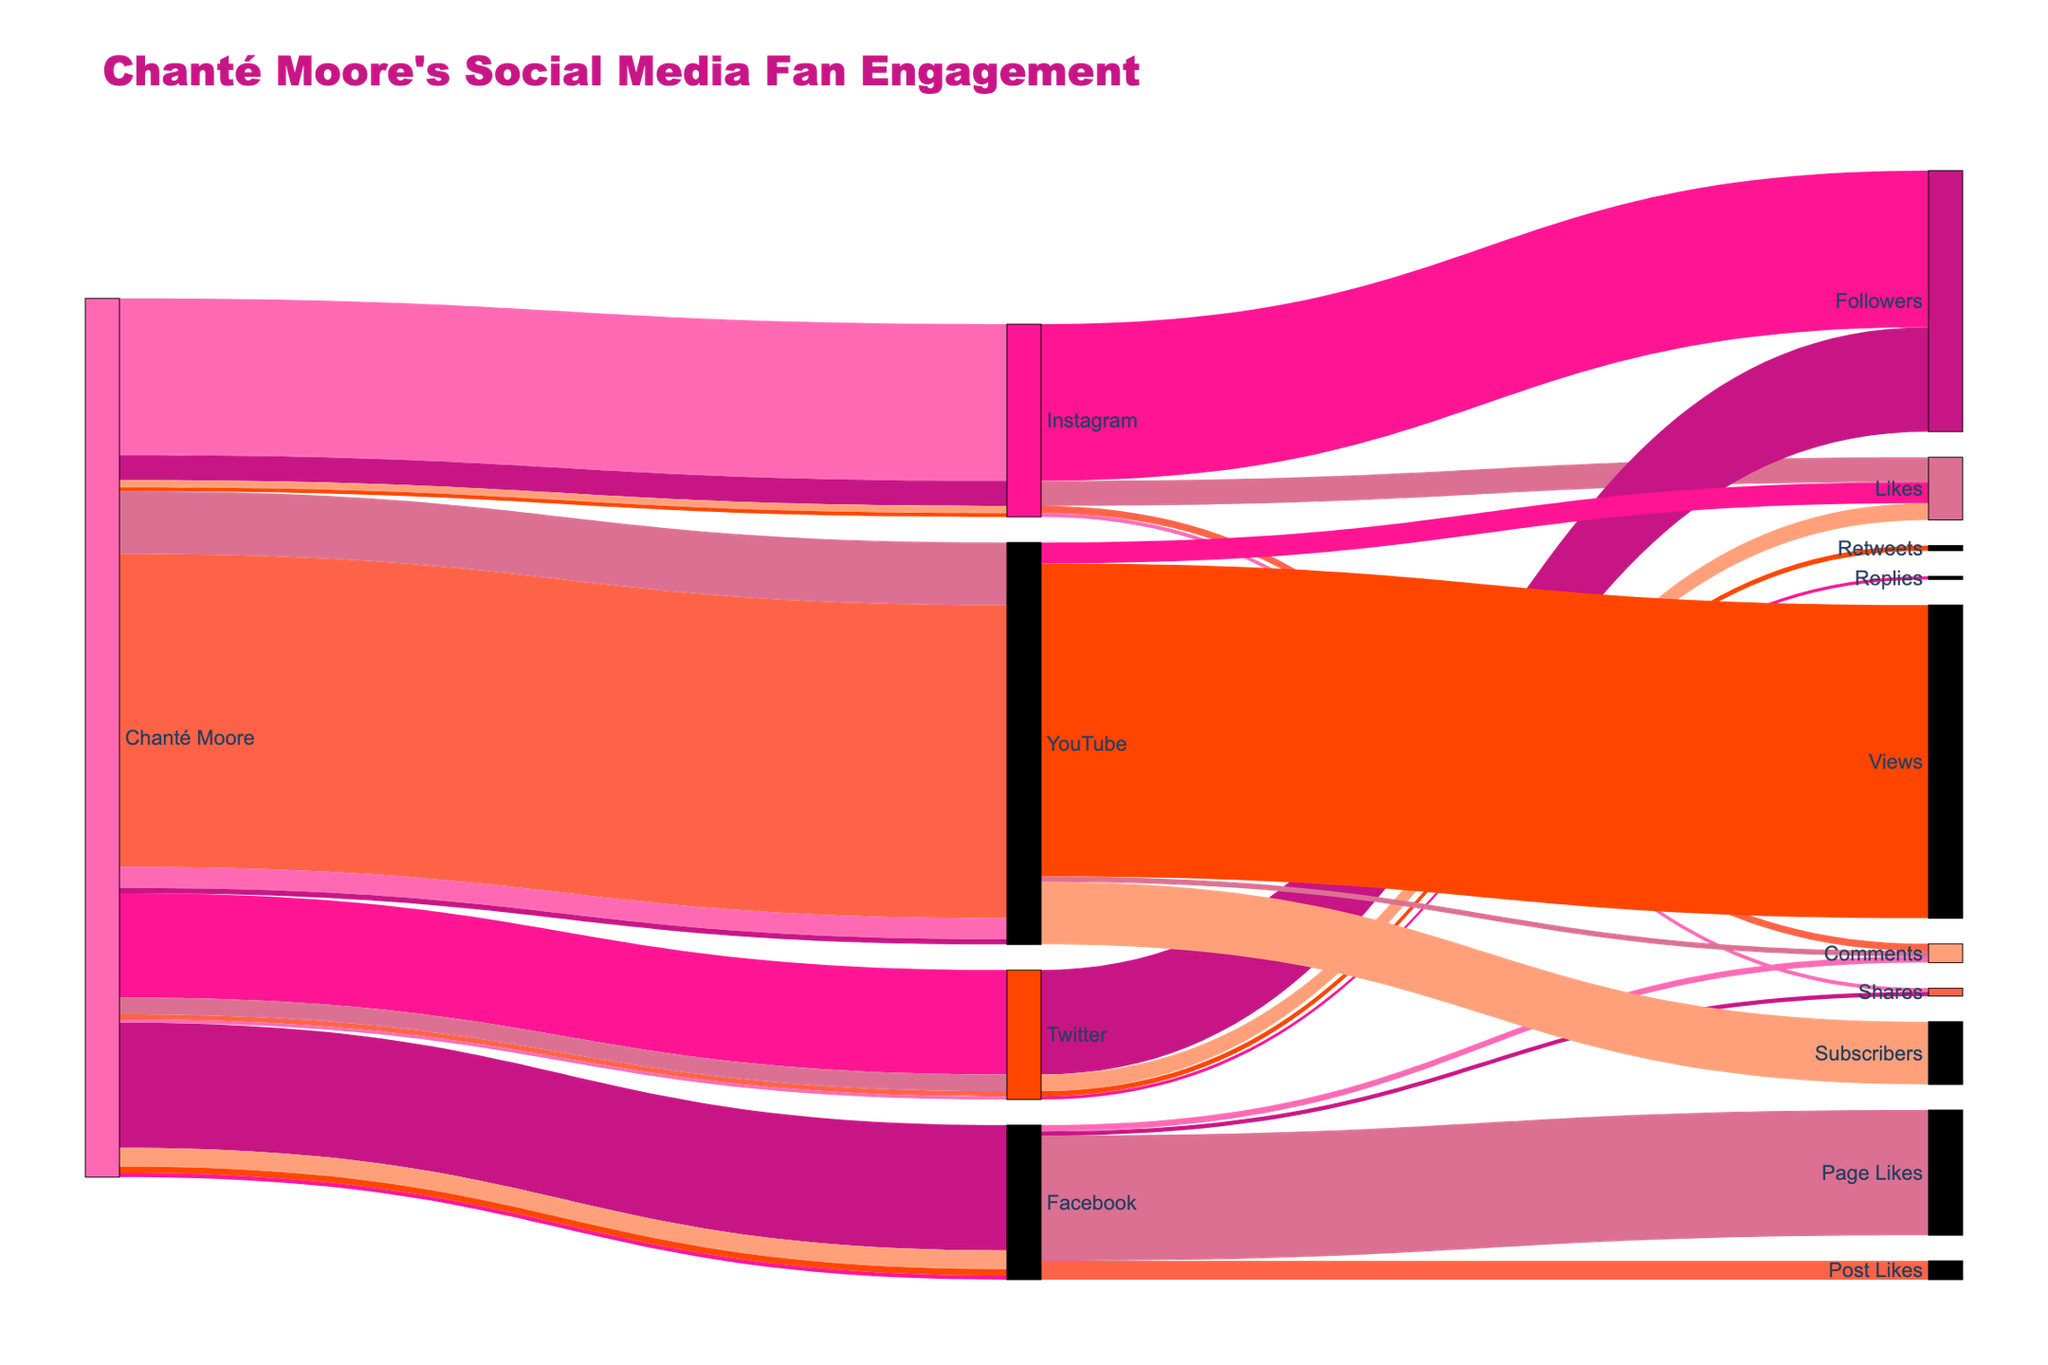What's the title of the figure? The title is usually found at the top of the figure. In this case, it reads "Chanté Moore's Social Media Fan Engagement".
Answer: Chanté Moore's Social Media Fan Engagement How many social media platforms are shown? By examining the nodes connected to "Chanté Moore," we see Instagram, Twitter, Facebook, and YouTube.
Answer: 4 What type of interaction has the highest value on YouTube? Identify the node for YouTube, then check the connections. The "Views" interaction has the highest value (1,500,000).
Answer: Views Which platform has the largest number of shares? Compare the share values for each platform. Facebook has 20,000 shares which is more than Instagram's 18,000 shares. Twitter and YouTube do not have a share interaction.
Answer: Facebook How many total followers does Chanté Moore have across all platforms? Sum the values of followers (or equivalent) for each platform: Instagram (750,000), Twitter (500,000), Facebook (600,000 page likes), YouTube (300,000 subscribers). Total is 750,000 + 500,000 + 600,000 + 300,000.
Answer: 2,150,000 What is the combined total of interactions (likes, comments, shares, etc.) for Instagram? Add the values of different interactions for Instagram: 120,000 (Likes) + 35,000 (Comments) + 18,000 (Shares) + 750,000 (Followers).
Answer: 923,000 Compare the number of page likes on Facebook to subscribers on YouTube. Which is higher? Facebook page likes are 600,000 while YouTube subscribers are 300,000.
Answer: Facebook Which interaction type is the most common across all platforms (consider the ones explicitly listed like "Followers", "Likes", "Comments", etc.)? Check the interactions mentioned for each platform and see which appears the most frequently. "Likes" appears on Instagram, Twitter, Facebook, and YouTube.
Answer: Likes How many interactions on Twitter are not related to likes or followers? The interactions other than likes or followers on Twitter are Retweets (25,000) and Replies (15,000).
Answer: 2 What's the average number of likes per post across all platforms? Sum all likes: Instagram (120,000) + Twitter (80,000) + Facebook (90,000) + YouTube (100,000) = 390,000. There are 4 platforms, so average is 390,000 / 4.
Answer: 97,500 